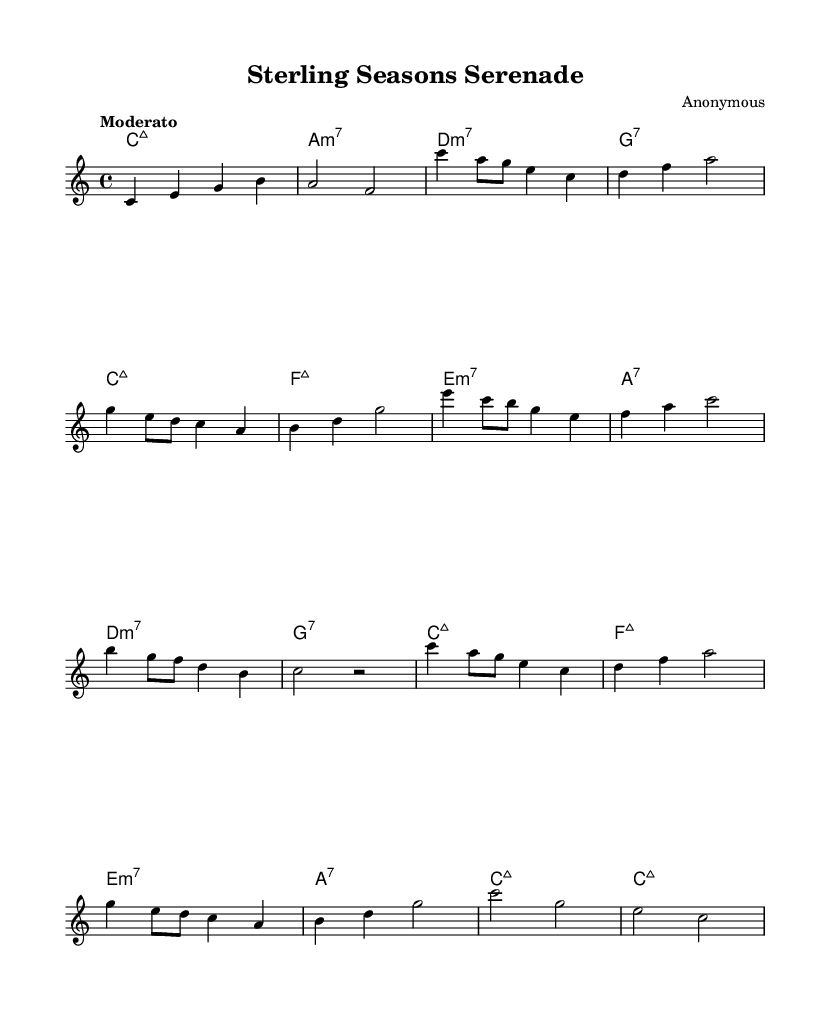what is the key signature of this music? The key signature is C major, which has no sharps or flats.
Answer: C major what is the time signature of this music? The time signature is indicated at the beginning of the piece as 4/4, which means there are four beats in each measure.
Answer: 4/4 what is the tempo marking of this piece? The tempo is marked as "Moderato", indicating a moderate pace in the performance.
Answer: Moderato how many measures are in section A? Section A is repeated twice in the music; each occurrence consists of four measures, so there are a total of eight measures in section A.
Answer: 8 what is the pattern of chord changes in measure 1? The first measure shows a C major seventh chord, which consists of the notes C, E, G, and B, indicating a jazz harmony.
Answer: C major seventh how does the melody change between sections A and B? Section A features a melodic phrase centered around C and A, while section B introduces different melodic motifs starting on E and C, creating contrast in themes.
Answer: Different melodic motifs what jazz characteristic is evident in the harmonies used? The piece uses extended harmonies, such as major seventh and minor seventh chords, which are common in jazz for creating more complex and rich sounds.
Answer: Extended harmonies 